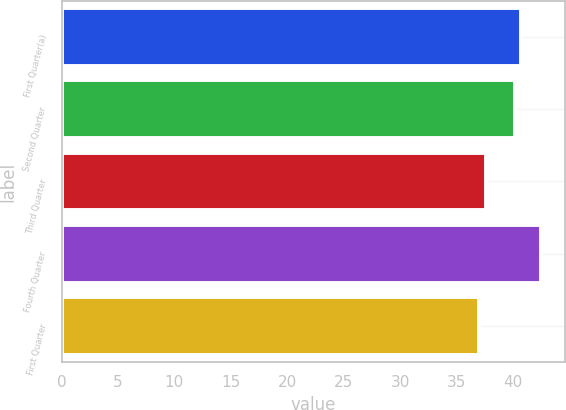Convert chart. <chart><loc_0><loc_0><loc_500><loc_500><bar_chart><fcel>First Quarter(a)<fcel>Second Quarter<fcel>Third Quarter<fcel>Fourth Quarter<fcel>First Quarter<nl><fcel>40.71<fcel>40.16<fcel>37.58<fcel>42.46<fcel>37<nl></chart> 